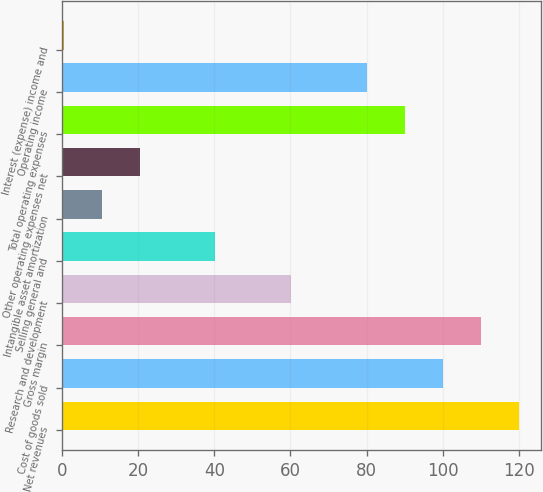Convert chart. <chart><loc_0><loc_0><loc_500><loc_500><bar_chart><fcel>Net revenues<fcel>Cost of goods sold<fcel>Gross margin<fcel>Research and development<fcel>Selling general and<fcel>Intangible asset amortization<fcel>Other operating expenses net<fcel>Total operating expenses<fcel>Operating income<fcel>Interest (expense) income and<nl><fcel>119.9<fcel>100<fcel>109.95<fcel>60.2<fcel>40.3<fcel>10.45<fcel>20.4<fcel>90.05<fcel>80.1<fcel>0.5<nl></chart> 